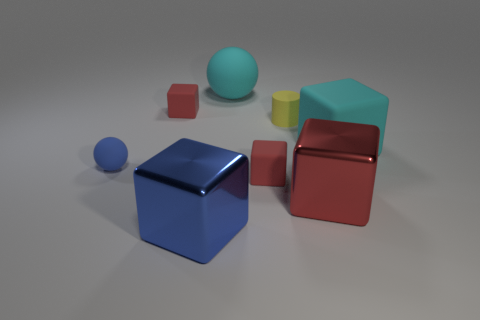How many red blocks must be subtracted to get 1 red blocks? 2 Subtract all gray cylinders. How many red cubes are left? 3 Subtract 2 blocks. How many blocks are left? 3 Subtract all blue cubes. How many cubes are left? 4 Subtract all cyan cubes. How many cubes are left? 4 Subtract all yellow blocks. Subtract all blue cylinders. How many blocks are left? 5 Add 1 big gray matte cubes. How many objects exist? 9 Subtract all balls. How many objects are left? 6 Add 6 large metallic objects. How many large metallic objects exist? 8 Subtract 0 brown blocks. How many objects are left? 8 